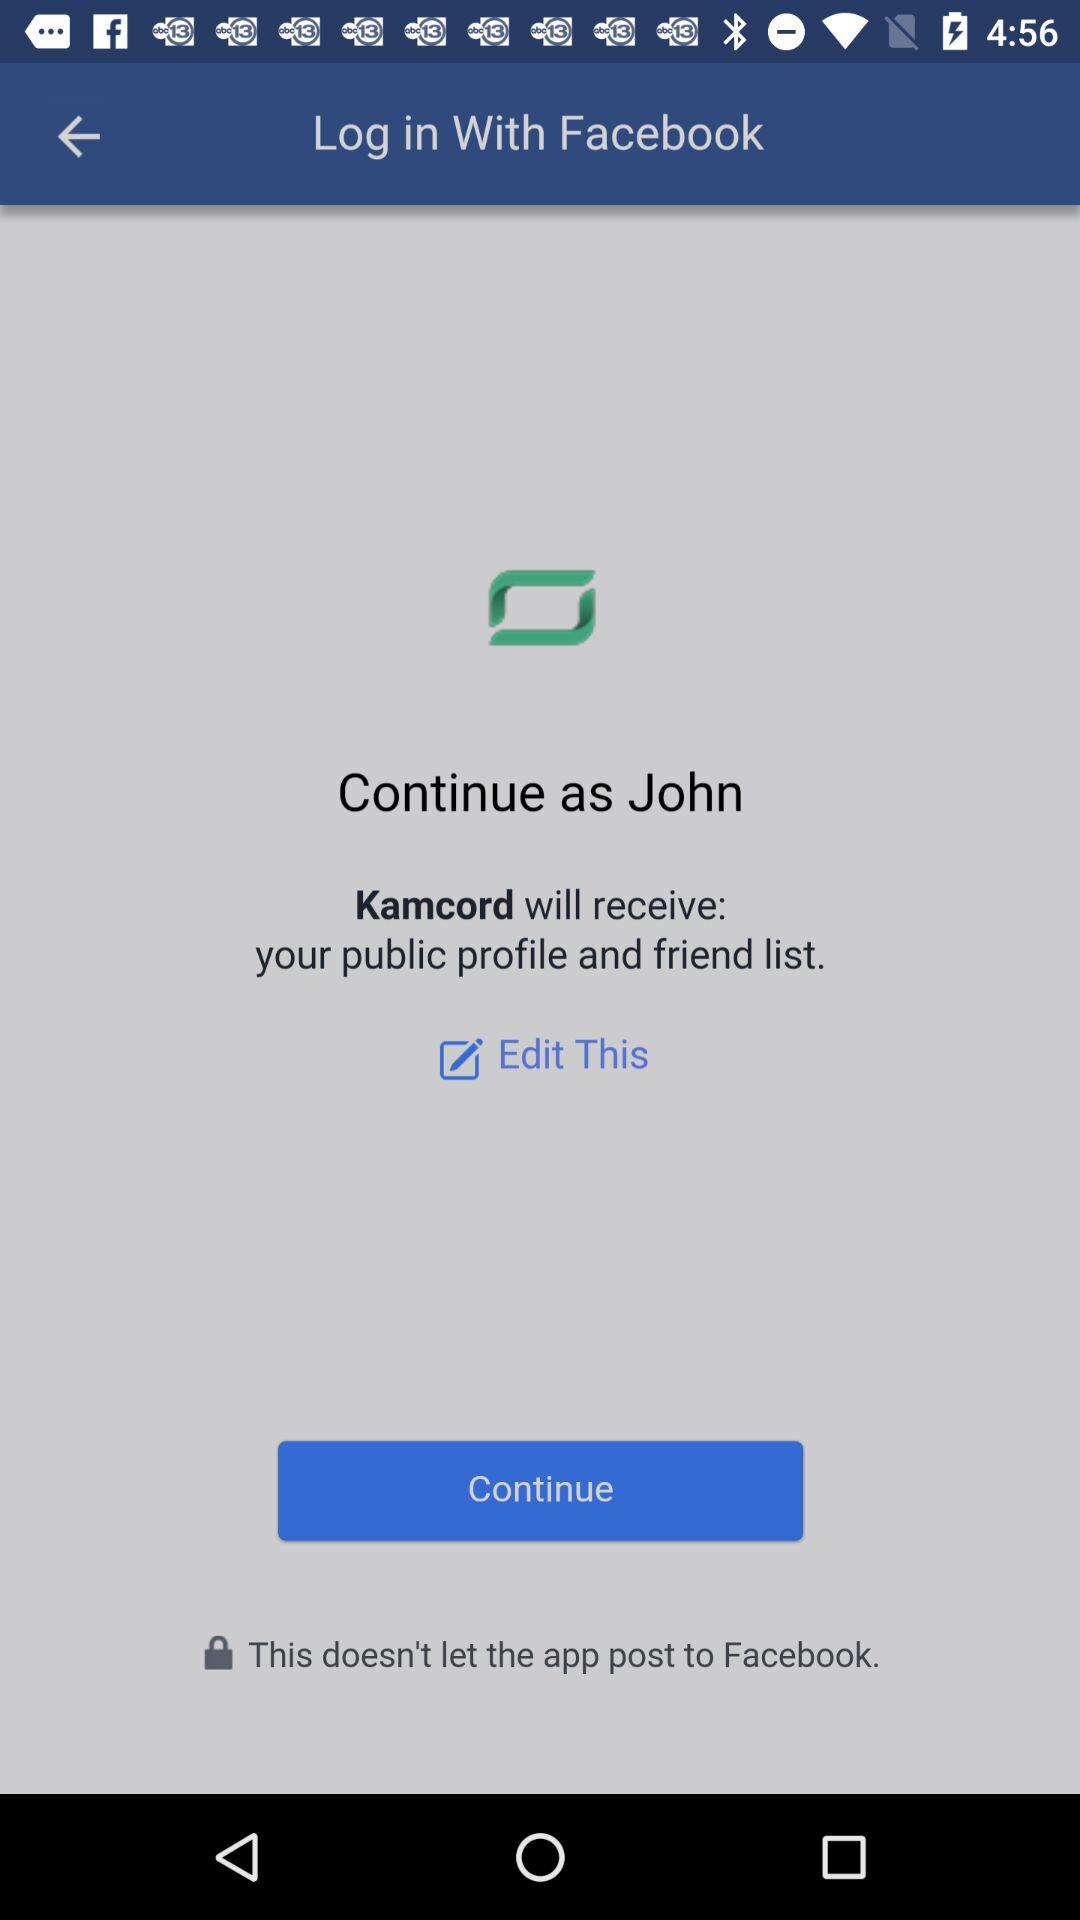What application is asking for the permission? The application asking for permission is "Kamcord". 